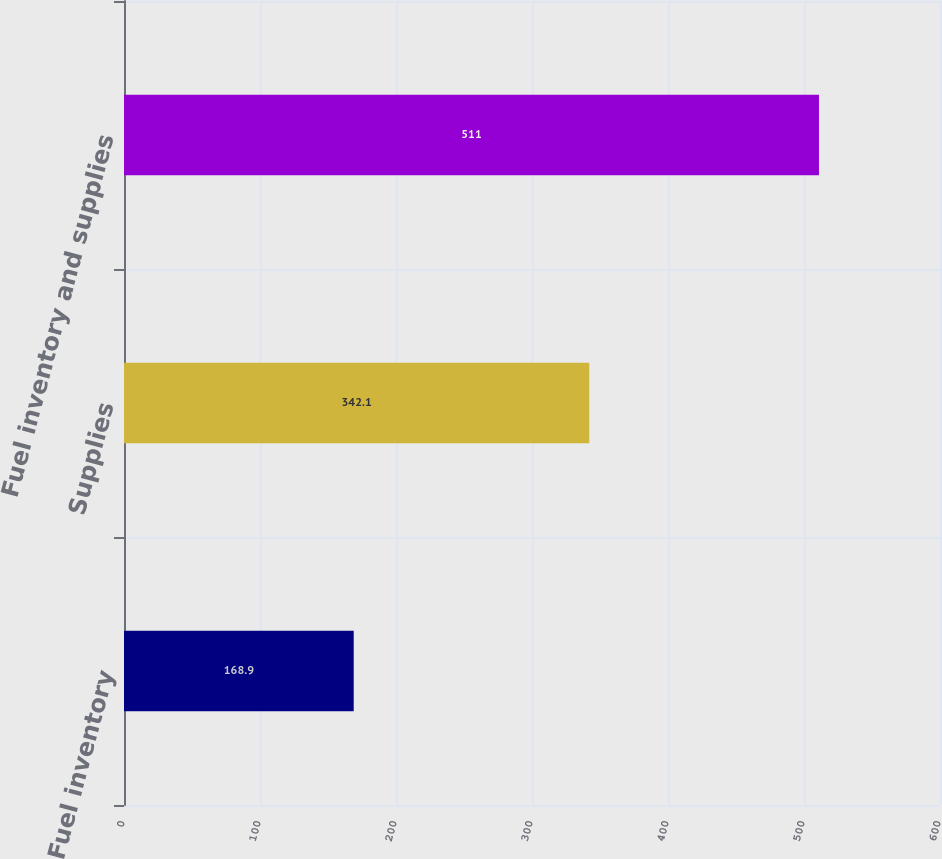Convert chart. <chart><loc_0><loc_0><loc_500><loc_500><bar_chart><fcel>Fuel inventory<fcel>Supplies<fcel>Fuel inventory and supplies<nl><fcel>168.9<fcel>342.1<fcel>511<nl></chart> 